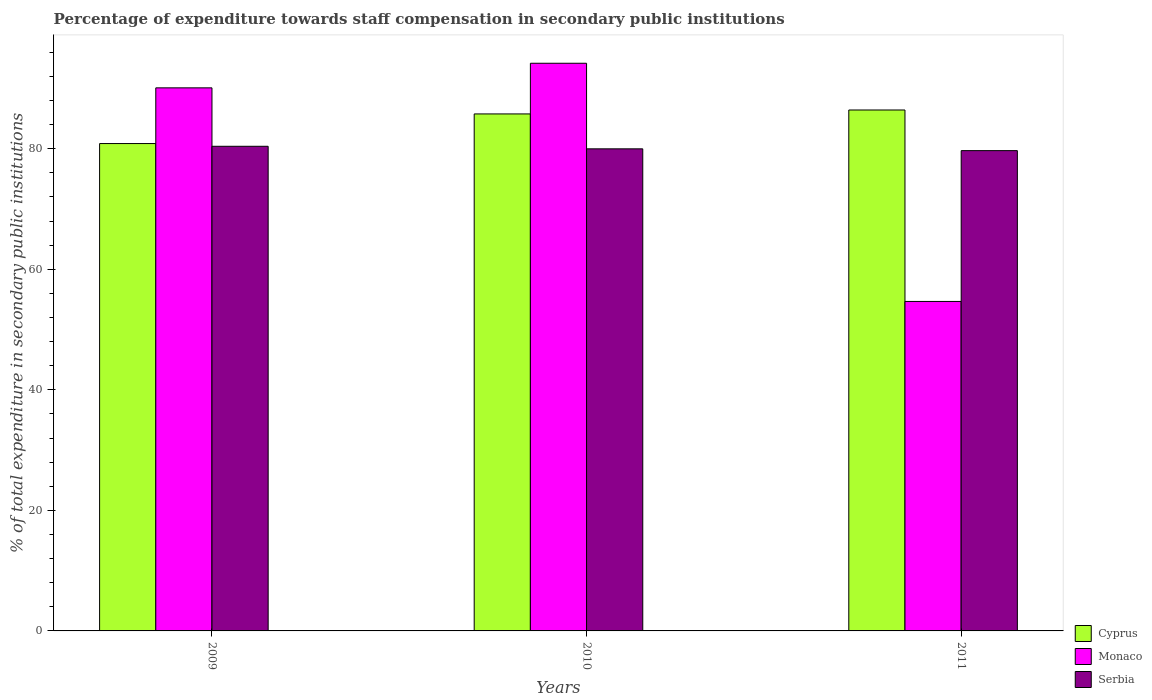How many groups of bars are there?
Your answer should be compact. 3. Are the number of bars per tick equal to the number of legend labels?
Offer a very short reply. Yes. Are the number of bars on each tick of the X-axis equal?
Keep it short and to the point. Yes. How many bars are there on the 1st tick from the left?
Your answer should be very brief. 3. How many bars are there on the 3rd tick from the right?
Offer a terse response. 3. In how many cases, is the number of bars for a given year not equal to the number of legend labels?
Provide a short and direct response. 0. What is the percentage of expenditure towards staff compensation in Cyprus in 2009?
Make the answer very short. 80.85. Across all years, what is the maximum percentage of expenditure towards staff compensation in Cyprus?
Offer a terse response. 86.42. Across all years, what is the minimum percentage of expenditure towards staff compensation in Monaco?
Your response must be concise. 54.66. In which year was the percentage of expenditure towards staff compensation in Serbia minimum?
Give a very brief answer. 2011. What is the total percentage of expenditure towards staff compensation in Serbia in the graph?
Give a very brief answer. 240.04. What is the difference between the percentage of expenditure towards staff compensation in Cyprus in 2009 and that in 2011?
Your answer should be compact. -5.57. What is the difference between the percentage of expenditure towards staff compensation in Monaco in 2011 and the percentage of expenditure towards staff compensation in Serbia in 2009?
Give a very brief answer. -25.74. What is the average percentage of expenditure towards staff compensation in Cyprus per year?
Your answer should be very brief. 84.34. In the year 2009, what is the difference between the percentage of expenditure towards staff compensation in Serbia and percentage of expenditure towards staff compensation in Monaco?
Your response must be concise. -9.69. What is the ratio of the percentage of expenditure towards staff compensation in Serbia in 2010 to that in 2011?
Your response must be concise. 1. Is the percentage of expenditure towards staff compensation in Serbia in 2010 less than that in 2011?
Your answer should be compact. No. What is the difference between the highest and the second highest percentage of expenditure towards staff compensation in Cyprus?
Ensure brevity in your answer.  0.65. What is the difference between the highest and the lowest percentage of expenditure towards staff compensation in Serbia?
Provide a succinct answer. 0.72. Is the sum of the percentage of expenditure towards staff compensation in Cyprus in 2009 and 2010 greater than the maximum percentage of expenditure towards staff compensation in Monaco across all years?
Your response must be concise. Yes. What does the 3rd bar from the left in 2009 represents?
Keep it short and to the point. Serbia. What does the 1st bar from the right in 2009 represents?
Offer a very short reply. Serbia. Is it the case that in every year, the sum of the percentage of expenditure towards staff compensation in Serbia and percentage of expenditure towards staff compensation in Cyprus is greater than the percentage of expenditure towards staff compensation in Monaco?
Keep it short and to the point. Yes. How many bars are there?
Offer a very short reply. 9. Are all the bars in the graph horizontal?
Keep it short and to the point. No. How many years are there in the graph?
Keep it short and to the point. 3. Are the values on the major ticks of Y-axis written in scientific E-notation?
Offer a very short reply. No. Does the graph contain grids?
Your answer should be compact. No. What is the title of the graph?
Your answer should be compact. Percentage of expenditure towards staff compensation in secondary public institutions. Does "Israel" appear as one of the legend labels in the graph?
Give a very brief answer. No. What is the label or title of the Y-axis?
Your answer should be very brief. % of total expenditure in secondary public institutions. What is the % of total expenditure in secondary public institutions in Cyprus in 2009?
Offer a very short reply. 80.85. What is the % of total expenditure in secondary public institutions of Monaco in 2009?
Your response must be concise. 90.09. What is the % of total expenditure in secondary public institutions of Serbia in 2009?
Offer a terse response. 80.39. What is the % of total expenditure in secondary public institutions in Cyprus in 2010?
Keep it short and to the point. 85.76. What is the % of total expenditure in secondary public institutions in Monaco in 2010?
Keep it short and to the point. 94.17. What is the % of total expenditure in secondary public institutions in Serbia in 2010?
Give a very brief answer. 79.97. What is the % of total expenditure in secondary public institutions in Cyprus in 2011?
Offer a very short reply. 86.42. What is the % of total expenditure in secondary public institutions in Monaco in 2011?
Provide a short and direct response. 54.66. What is the % of total expenditure in secondary public institutions of Serbia in 2011?
Your response must be concise. 79.67. Across all years, what is the maximum % of total expenditure in secondary public institutions of Cyprus?
Keep it short and to the point. 86.42. Across all years, what is the maximum % of total expenditure in secondary public institutions of Monaco?
Your answer should be very brief. 94.17. Across all years, what is the maximum % of total expenditure in secondary public institutions in Serbia?
Offer a terse response. 80.39. Across all years, what is the minimum % of total expenditure in secondary public institutions of Cyprus?
Offer a terse response. 80.85. Across all years, what is the minimum % of total expenditure in secondary public institutions of Monaco?
Ensure brevity in your answer.  54.66. Across all years, what is the minimum % of total expenditure in secondary public institutions of Serbia?
Make the answer very short. 79.67. What is the total % of total expenditure in secondary public institutions in Cyprus in the graph?
Your answer should be very brief. 253.03. What is the total % of total expenditure in secondary public institutions of Monaco in the graph?
Keep it short and to the point. 238.92. What is the total % of total expenditure in secondary public institutions in Serbia in the graph?
Offer a terse response. 240.04. What is the difference between the % of total expenditure in secondary public institutions in Cyprus in 2009 and that in 2010?
Your response must be concise. -4.91. What is the difference between the % of total expenditure in secondary public institutions of Monaco in 2009 and that in 2010?
Your answer should be compact. -4.08. What is the difference between the % of total expenditure in secondary public institutions in Serbia in 2009 and that in 2010?
Your response must be concise. 0.42. What is the difference between the % of total expenditure in secondary public institutions of Cyprus in 2009 and that in 2011?
Make the answer very short. -5.57. What is the difference between the % of total expenditure in secondary public institutions in Monaco in 2009 and that in 2011?
Make the answer very short. 35.43. What is the difference between the % of total expenditure in secondary public institutions of Serbia in 2009 and that in 2011?
Your answer should be very brief. 0.72. What is the difference between the % of total expenditure in secondary public institutions in Cyprus in 2010 and that in 2011?
Provide a short and direct response. -0.65. What is the difference between the % of total expenditure in secondary public institutions in Monaco in 2010 and that in 2011?
Offer a terse response. 39.51. What is the difference between the % of total expenditure in secondary public institutions in Serbia in 2010 and that in 2011?
Provide a succinct answer. 0.3. What is the difference between the % of total expenditure in secondary public institutions of Cyprus in 2009 and the % of total expenditure in secondary public institutions of Monaco in 2010?
Offer a terse response. -13.32. What is the difference between the % of total expenditure in secondary public institutions of Cyprus in 2009 and the % of total expenditure in secondary public institutions of Serbia in 2010?
Ensure brevity in your answer.  0.88. What is the difference between the % of total expenditure in secondary public institutions of Monaco in 2009 and the % of total expenditure in secondary public institutions of Serbia in 2010?
Your response must be concise. 10.12. What is the difference between the % of total expenditure in secondary public institutions in Cyprus in 2009 and the % of total expenditure in secondary public institutions in Monaco in 2011?
Keep it short and to the point. 26.19. What is the difference between the % of total expenditure in secondary public institutions in Cyprus in 2009 and the % of total expenditure in secondary public institutions in Serbia in 2011?
Ensure brevity in your answer.  1.18. What is the difference between the % of total expenditure in secondary public institutions in Monaco in 2009 and the % of total expenditure in secondary public institutions in Serbia in 2011?
Your answer should be compact. 10.41. What is the difference between the % of total expenditure in secondary public institutions of Cyprus in 2010 and the % of total expenditure in secondary public institutions of Monaco in 2011?
Ensure brevity in your answer.  31.11. What is the difference between the % of total expenditure in secondary public institutions in Cyprus in 2010 and the % of total expenditure in secondary public institutions in Serbia in 2011?
Your response must be concise. 6.09. What is the difference between the % of total expenditure in secondary public institutions of Monaco in 2010 and the % of total expenditure in secondary public institutions of Serbia in 2011?
Keep it short and to the point. 14.5. What is the average % of total expenditure in secondary public institutions of Cyprus per year?
Provide a succinct answer. 84.34. What is the average % of total expenditure in secondary public institutions of Monaco per year?
Offer a very short reply. 79.64. What is the average % of total expenditure in secondary public institutions of Serbia per year?
Offer a very short reply. 80.01. In the year 2009, what is the difference between the % of total expenditure in secondary public institutions in Cyprus and % of total expenditure in secondary public institutions in Monaco?
Ensure brevity in your answer.  -9.24. In the year 2009, what is the difference between the % of total expenditure in secondary public institutions in Cyprus and % of total expenditure in secondary public institutions in Serbia?
Offer a terse response. 0.46. In the year 2009, what is the difference between the % of total expenditure in secondary public institutions in Monaco and % of total expenditure in secondary public institutions in Serbia?
Your answer should be compact. 9.69. In the year 2010, what is the difference between the % of total expenditure in secondary public institutions in Cyprus and % of total expenditure in secondary public institutions in Monaco?
Provide a short and direct response. -8.41. In the year 2010, what is the difference between the % of total expenditure in secondary public institutions in Cyprus and % of total expenditure in secondary public institutions in Serbia?
Your answer should be very brief. 5.79. In the year 2010, what is the difference between the % of total expenditure in secondary public institutions of Monaco and % of total expenditure in secondary public institutions of Serbia?
Provide a short and direct response. 14.2. In the year 2011, what is the difference between the % of total expenditure in secondary public institutions in Cyprus and % of total expenditure in secondary public institutions in Monaco?
Make the answer very short. 31.76. In the year 2011, what is the difference between the % of total expenditure in secondary public institutions in Cyprus and % of total expenditure in secondary public institutions in Serbia?
Keep it short and to the point. 6.74. In the year 2011, what is the difference between the % of total expenditure in secondary public institutions of Monaco and % of total expenditure in secondary public institutions of Serbia?
Your answer should be very brief. -25.02. What is the ratio of the % of total expenditure in secondary public institutions in Cyprus in 2009 to that in 2010?
Offer a terse response. 0.94. What is the ratio of the % of total expenditure in secondary public institutions in Monaco in 2009 to that in 2010?
Offer a terse response. 0.96. What is the ratio of the % of total expenditure in secondary public institutions of Serbia in 2009 to that in 2010?
Ensure brevity in your answer.  1.01. What is the ratio of the % of total expenditure in secondary public institutions in Cyprus in 2009 to that in 2011?
Provide a short and direct response. 0.94. What is the ratio of the % of total expenditure in secondary public institutions in Monaco in 2009 to that in 2011?
Offer a very short reply. 1.65. What is the ratio of the % of total expenditure in secondary public institutions in Monaco in 2010 to that in 2011?
Offer a very short reply. 1.72. What is the ratio of the % of total expenditure in secondary public institutions in Serbia in 2010 to that in 2011?
Your response must be concise. 1. What is the difference between the highest and the second highest % of total expenditure in secondary public institutions in Cyprus?
Give a very brief answer. 0.65. What is the difference between the highest and the second highest % of total expenditure in secondary public institutions in Monaco?
Provide a short and direct response. 4.08. What is the difference between the highest and the second highest % of total expenditure in secondary public institutions in Serbia?
Your answer should be very brief. 0.42. What is the difference between the highest and the lowest % of total expenditure in secondary public institutions in Cyprus?
Your answer should be very brief. 5.57. What is the difference between the highest and the lowest % of total expenditure in secondary public institutions in Monaco?
Keep it short and to the point. 39.51. What is the difference between the highest and the lowest % of total expenditure in secondary public institutions in Serbia?
Give a very brief answer. 0.72. 